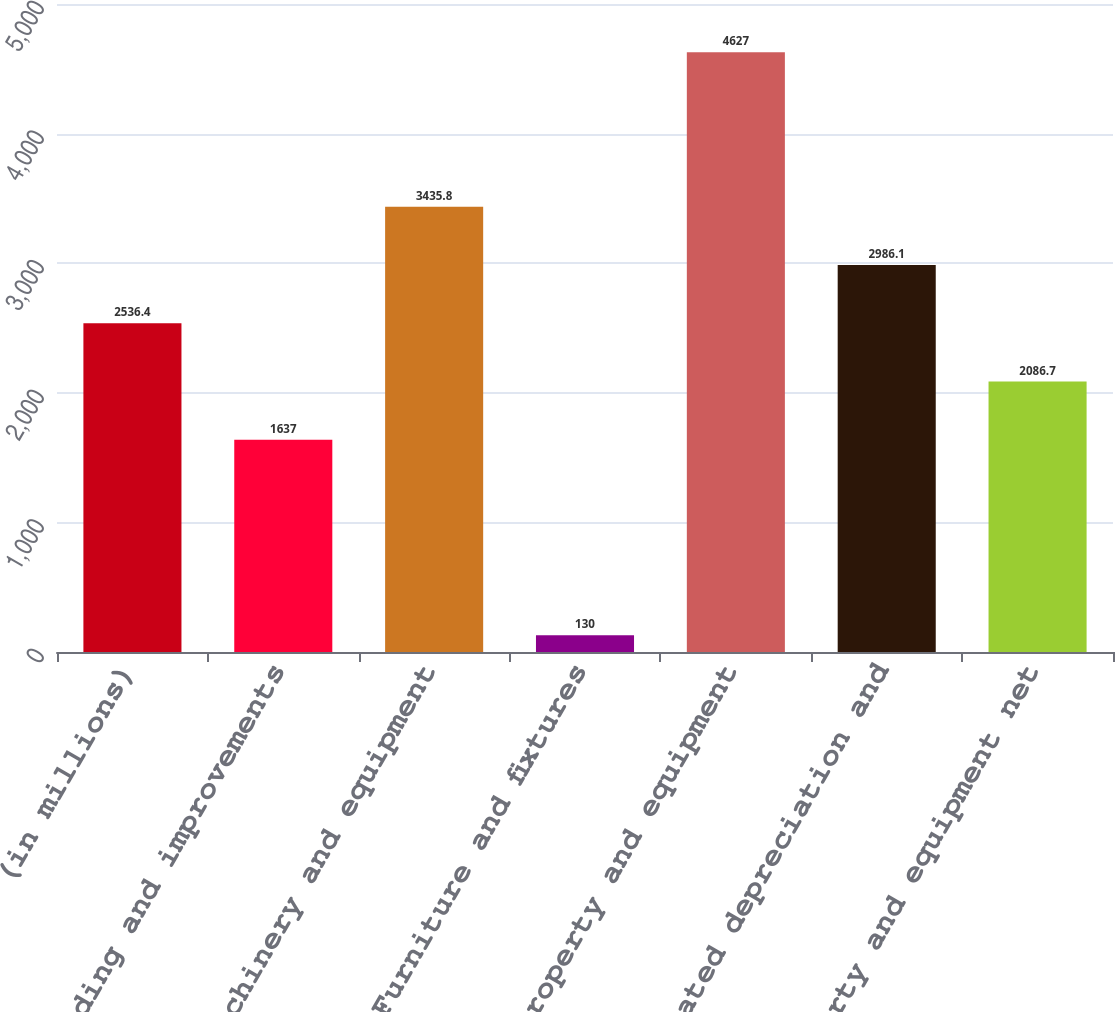<chart> <loc_0><loc_0><loc_500><loc_500><bar_chart><fcel>(in millions)<fcel>Land building and improvements<fcel>Machinery and equipment<fcel>Furniture and fixtures<fcel>Total property and equipment<fcel>Accumulated depreciation and<fcel>Property and equipment net<nl><fcel>2536.4<fcel>1637<fcel>3435.8<fcel>130<fcel>4627<fcel>2986.1<fcel>2086.7<nl></chart> 